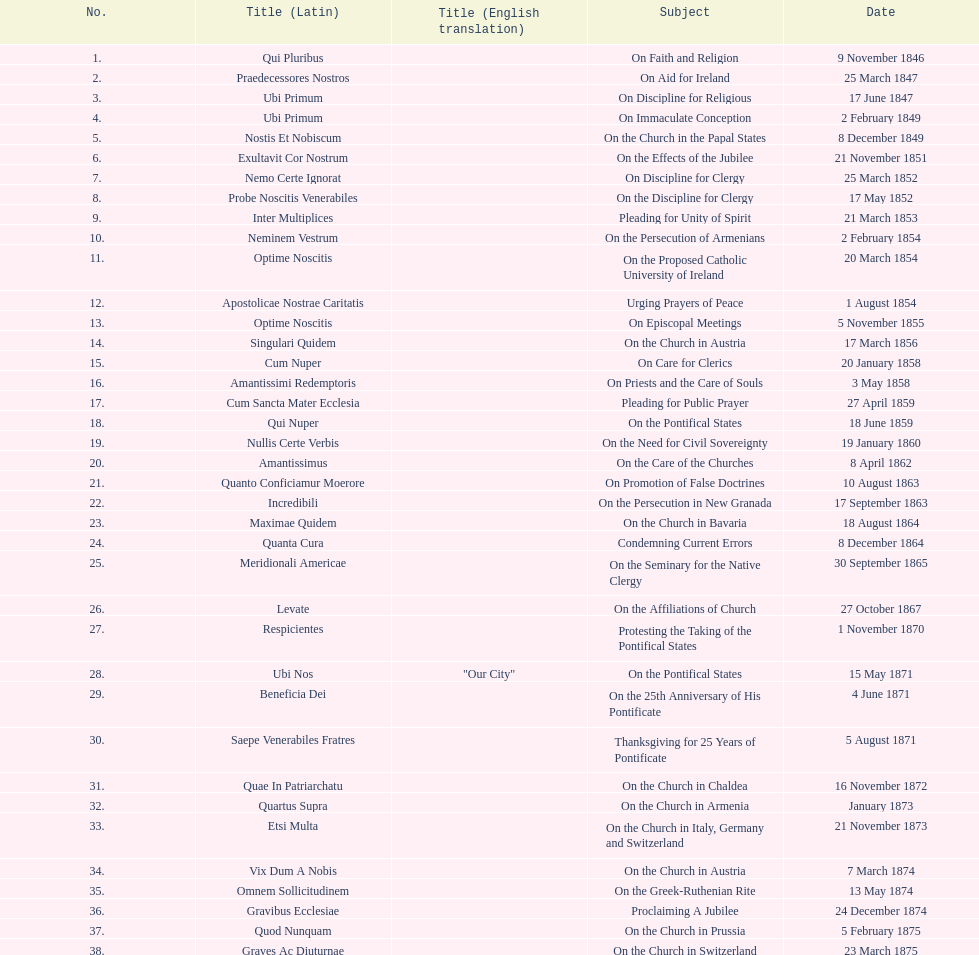What was the latin title for the encyclical published prior to the one discussing "on the church in bavaria"? Incredibili. Can you give me this table as a dict? {'header': ['No.', 'Title (Latin)', 'Title (English translation)', 'Subject', 'Date'], 'rows': [['1.', 'Qui Pluribus', '', 'On Faith and Religion', '9 November 1846'], ['2.', 'Praedecessores Nostros', '', 'On Aid for Ireland', '25 March 1847'], ['3.', 'Ubi Primum', '', 'On Discipline for Religious', '17 June 1847'], ['4.', 'Ubi Primum', '', 'On Immaculate Conception', '2 February 1849'], ['5.', 'Nostis Et Nobiscum', '', 'On the Church in the Papal States', '8 December 1849'], ['6.', 'Exultavit Cor Nostrum', '', 'On the Effects of the Jubilee', '21 November 1851'], ['7.', 'Nemo Certe Ignorat', '', 'On Discipline for Clergy', '25 March 1852'], ['8.', 'Probe Noscitis Venerabiles', '', 'On the Discipline for Clergy', '17 May 1852'], ['9.', 'Inter Multiplices', '', 'Pleading for Unity of Spirit', '21 March 1853'], ['10.', 'Neminem Vestrum', '', 'On the Persecution of Armenians', '2 February 1854'], ['11.', 'Optime Noscitis', '', 'On the Proposed Catholic University of Ireland', '20 March 1854'], ['12.', 'Apostolicae Nostrae Caritatis', '', 'Urging Prayers of Peace', '1 August 1854'], ['13.', 'Optime Noscitis', '', 'On Episcopal Meetings', '5 November 1855'], ['14.', 'Singulari Quidem', '', 'On the Church in Austria', '17 March 1856'], ['15.', 'Cum Nuper', '', 'On Care for Clerics', '20 January 1858'], ['16.', 'Amantissimi Redemptoris', '', 'On Priests and the Care of Souls', '3 May 1858'], ['17.', 'Cum Sancta Mater Ecclesia', '', 'Pleading for Public Prayer', '27 April 1859'], ['18.', 'Qui Nuper', '', 'On the Pontifical States', '18 June 1859'], ['19.', 'Nullis Certe Verbis', '', 'On the Need for Civil Sovereignty', '19 January 1860'], ['20.', 'Amantissimus', '', 'On the Care of the Churches', '8 April 1862'], ['21.', 'Quanto Conficiamur Moerore', '', 'On Promotion of False Doctrines', '10 August 1863'], ['22.', 'Incredibili', '', 'On the Persecution in New Granada', '17 September 1863'], ['23.', 'Maximae Quidem', '', 'On the Church in Bavaria', '18 August 1864'], ['24.', 'Quanta Cura', '', 'Condemning Current Errors', '8 December 1864'], ['25.', 'Meridionali Americae', '', 'On the Seminary for the Native Clergy', '30 September 1865'], ['26.', 'Levate', '', 'On the Affiliations of Church', '27 October 1867'], ['27.', 'Respicientes', '', 'Protesting the Taking of the Pontifical States', '1 November 1870'], ['28.', 'Ubi Nos', '"Our City"', 'On the Pontifical States', '15 May 1871'], ['29.', 'Beneficia Dei', '', 'On the 25th Anniversary of His Pontificate', '4 June 1871'], ['30.', 'Saepe Venerabiles Fratres', '', 'Thanksgiving for 25 Years of Pontificate', '5 August 1871'], ['31.', 'Quae In Patriarchatu', '', 'On the Church in Chaldea', '16 November 1872'], ['32.', 'Quartus Supra', '', 'On the Church in Armenia', 'January 1873'], ['33.', 'Etsi Multa', '', 'On the Church in Italy, Germany and Switzerland', '21 November 1873'], ['34.', 'Vix Dum A Nobis', '', 'On the Church in Austria', '7 March 1874'], ['35.', 'Omnem Sollicitudinem', '', 'On the Greek-Ruthenian Rite', '13 May 1874'], ['36.', 'Gravibus Ecclesiae', '', 'Proclaiming A Jubilee', '24 December 1874'], ['37.', 'Quod Nunquam', '', 'On the Church in Prussia', '5 February 1875'], ['38.', 'Graves Ac Diuturnae', '', 'On the Church in Switzerland', '23 March 1875']]} 